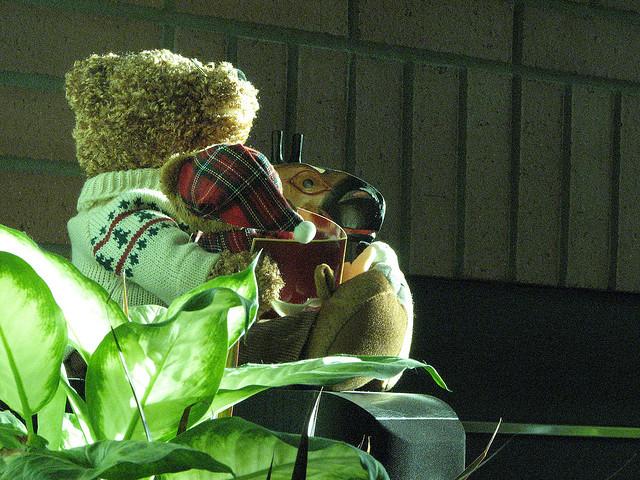What type of plant is that?
Write a very short answer. Fern. Do teddy bears normally wear jackets?
Answer briefly. No. Is the teddy bear wearing pants?
Concise answer only. Yes. 